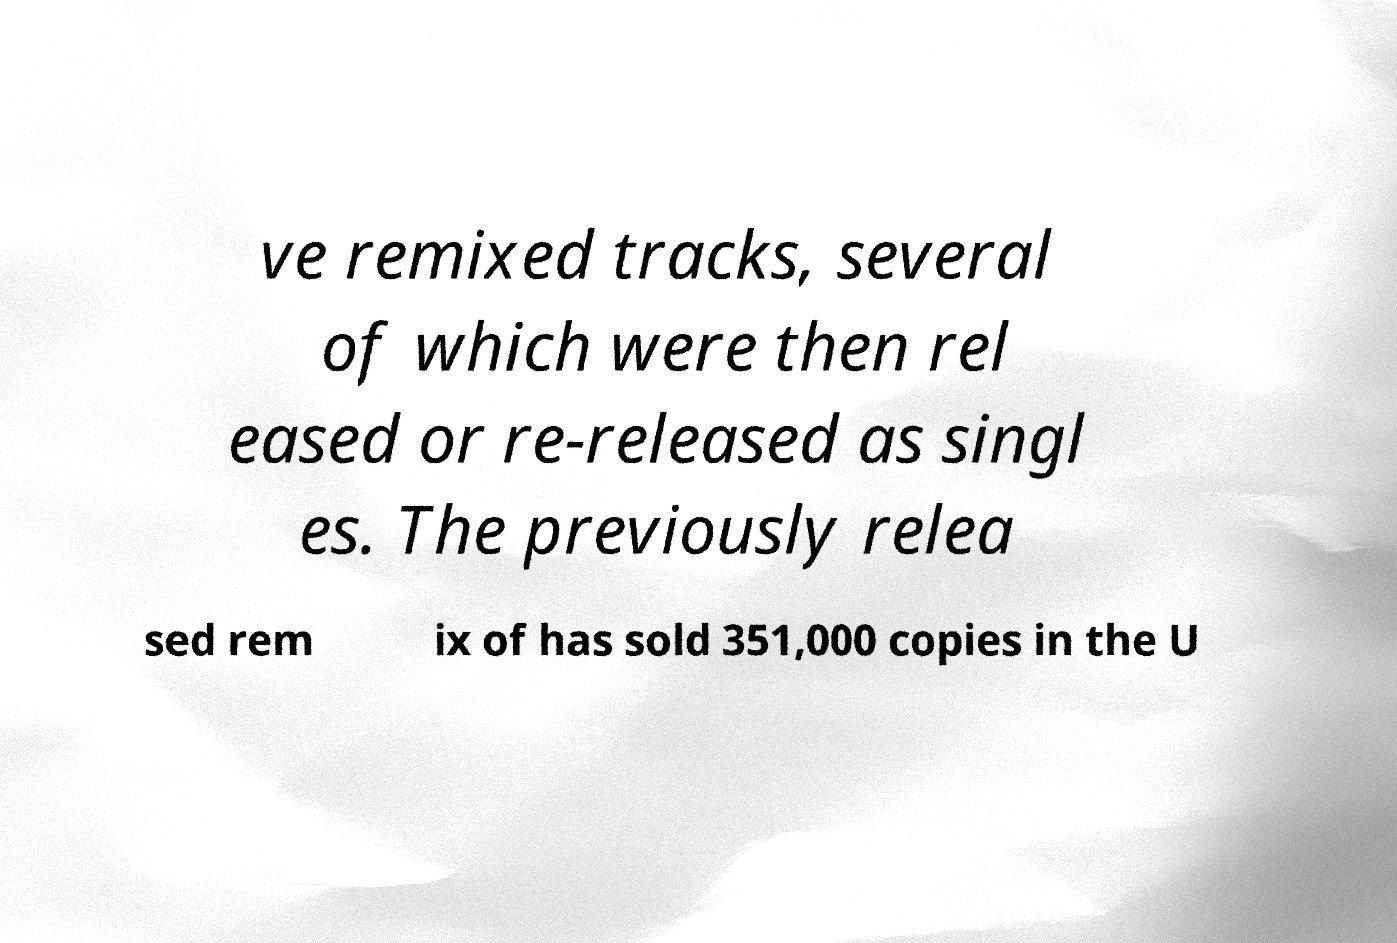There's text embedded in this image that I need extracted. Can you transcribe it verbatim? ve remixed tracks, several of which were then rel eased or re-released as singl es. The previously relea sed rem ix of has sold 351,000 copies in the U 